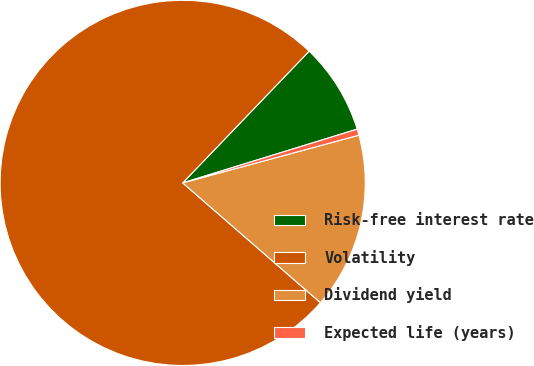Convert chart. <chart><loc_0><loc_0><loc_500><loc_500><pie_chart><fcel>Risk-free interest rate<fcel>Volatility<fcel>Dividend yield<fcel>Expected life (years)<nl><fcel>8.07%<fcel>75.78%<fcel>15.6%<fcel>0.55%<nl></chart> 